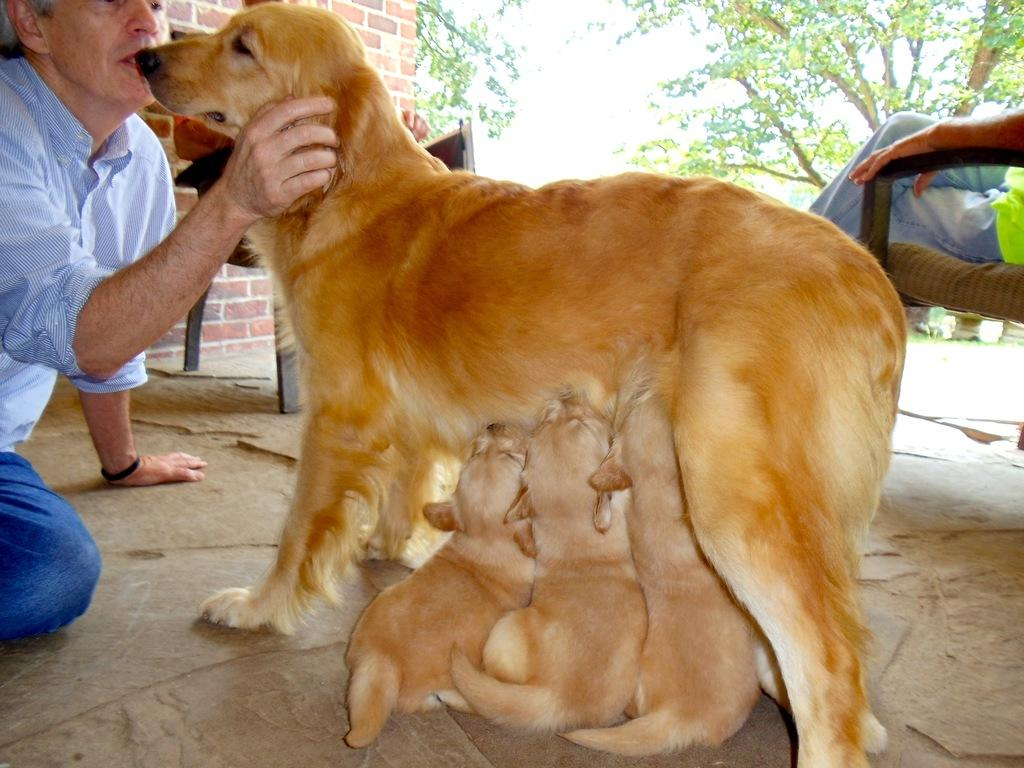What is the person holding in the image? The person is holding a dog in the image. What other animals can be seen in the image? There are puppies in the image. What is the person sitting on in the image? The person is sitting on a chair in the image. What is the background of the image? There is a wall, trees, and the sky visible in the image. What is the rate at which the things in the pan are cooking in the image? There is no pan or cooking activity present in the image. 